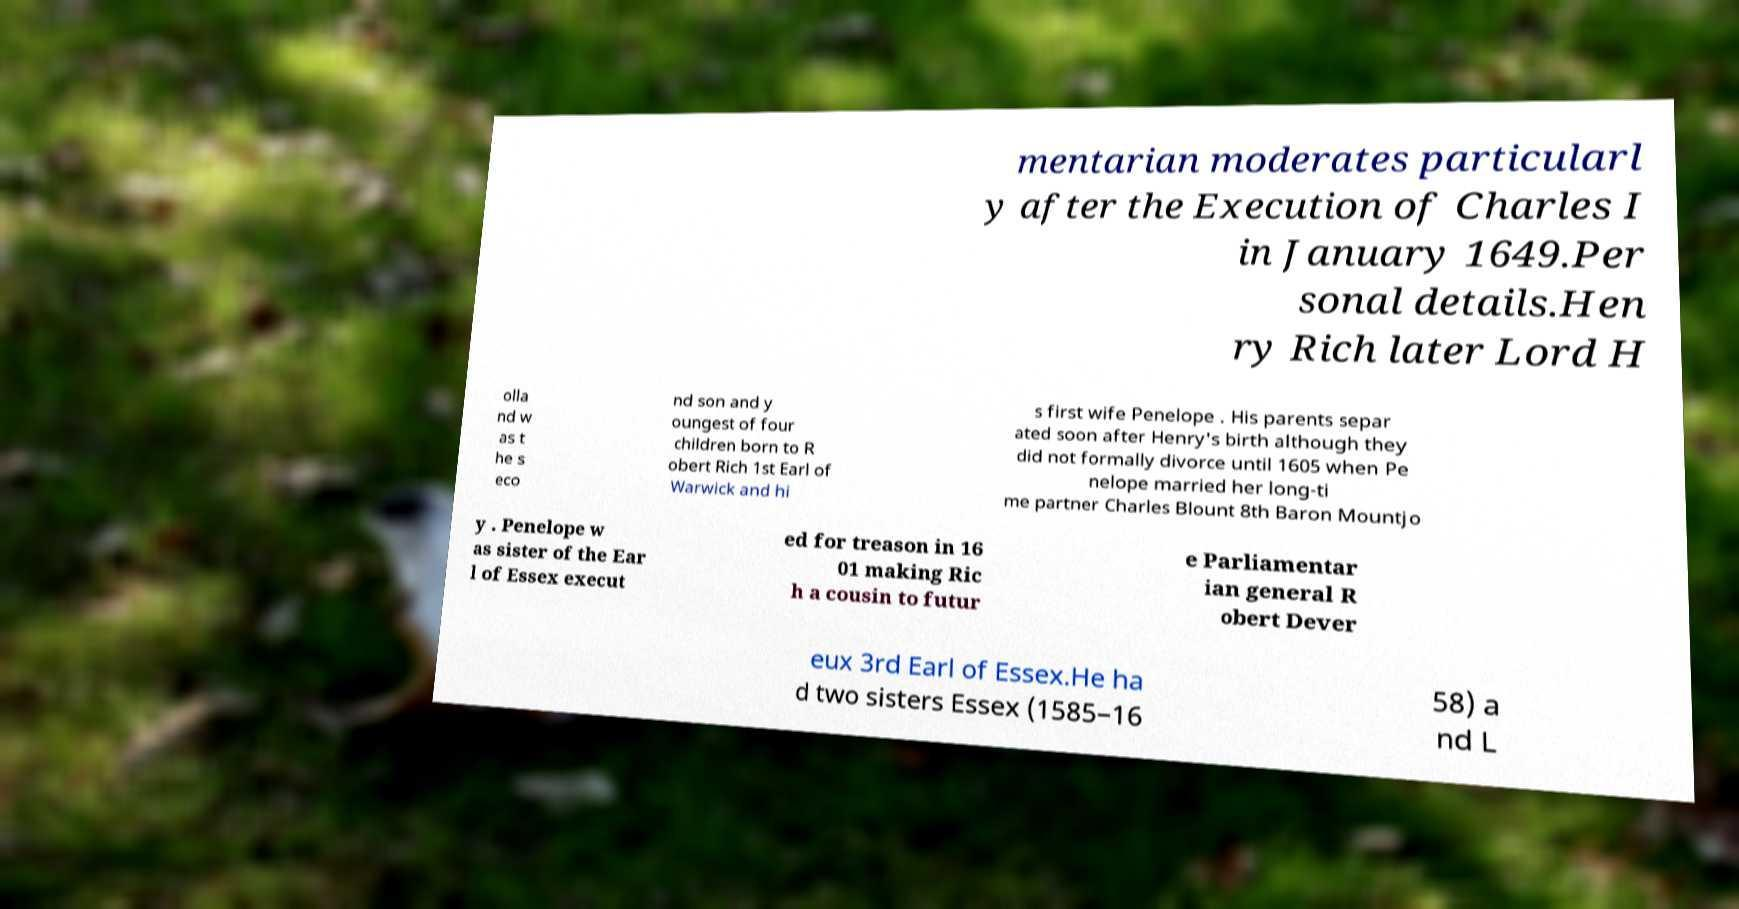I need the written content from this picture converted into text. Can you do that? mentarian moderates particularl y after the Execution of Charles I in January 1649.Per sonal details.Hen ry Rich later Lord H olla nd w as t he s eco nd son and y oungest of four children born to R obert Rich 1st Earl of Warwick and hi s first wife Penelope . His parents separ ated soon after Henry's birth although they did not formally divorce until 1605 when Pe nelope married her long-ti me partner Charles Blount 8th Baron Mountjo y . Penelope w as sister of the Ear l of Essex execut ed for treason in 16 01 making Ric h a cousin to futur e Parliamentar ian general R obert Dever eux 3rd Earl of Essex.He ha d two sisters Essex (1585–16 58) a nd L 